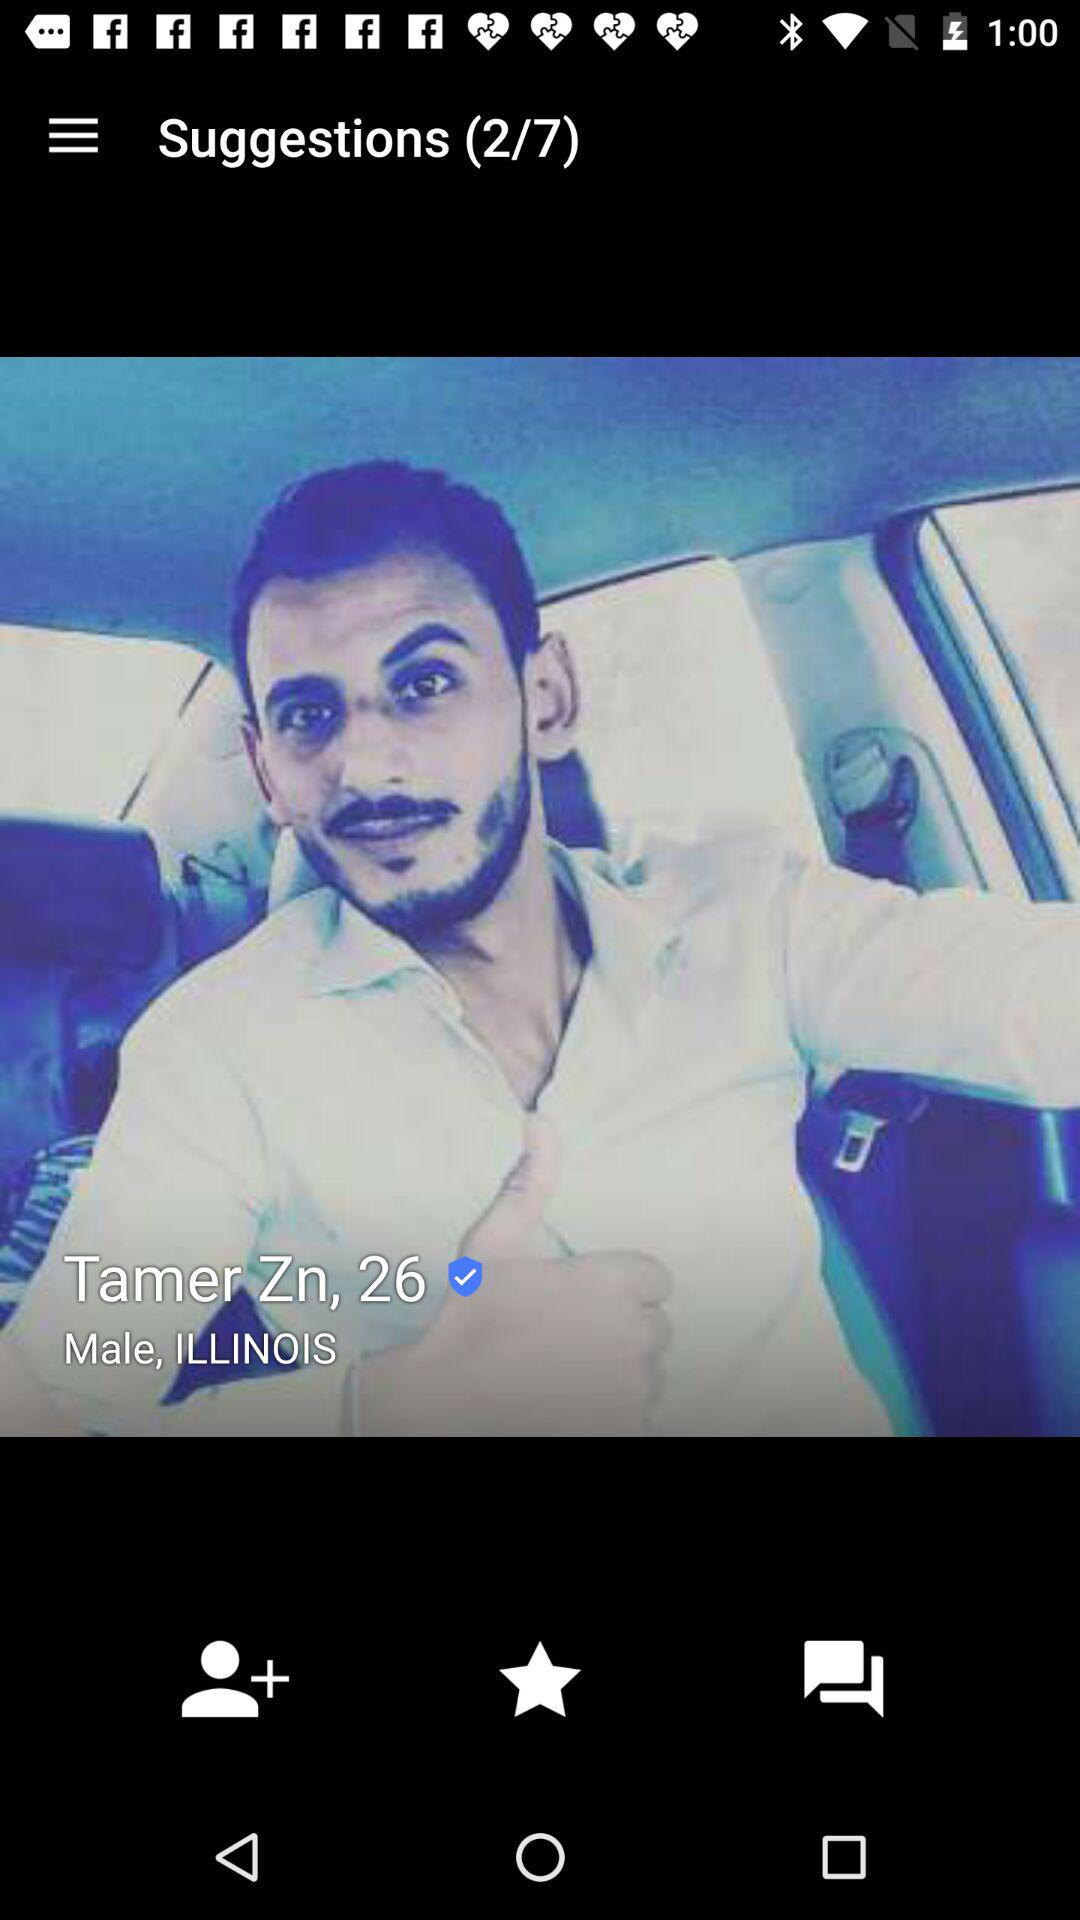What is location? The location is "ILLINOIS". 